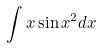<formula> <loc_0><loc_0><loc_500><loc_500>\int x \sin x ^ { 2 } d x</formula> 